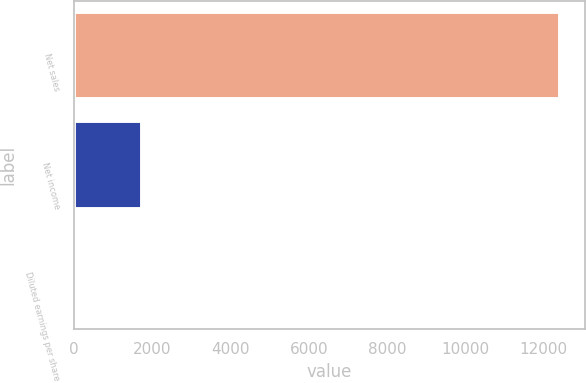Convert chart to OTSL. <chart><loc_0><loc_0><loc_500><loc_500><bar_chart><fcel>Net sales<fcel>Net income<fcel>Diluted earnings per share<nl><fcel>12429<fcel>1744<fcel>4.18<nl></chart> 